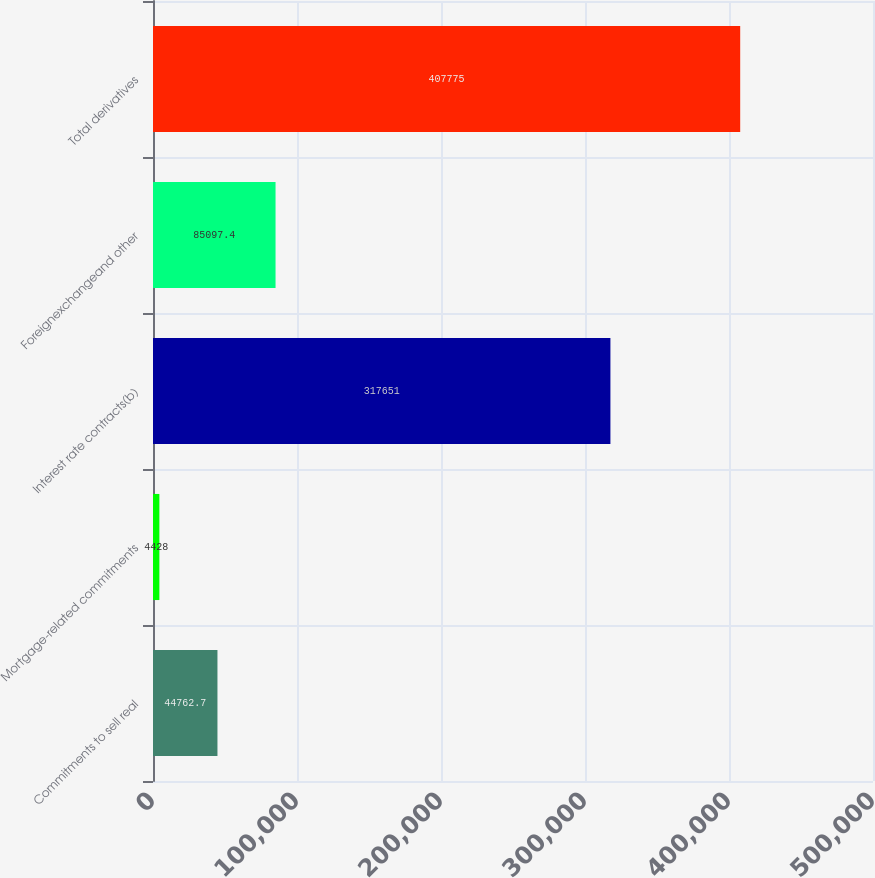Convert chart. <chart><loc_0><loc_0><loc_500><loc_500><bar_chart><fcel>Commitments to sell real<fcel>Mortgage-related commitments<fcel>Interest rate contracts(b)<fcel>Foreignexchangeand other<fcel>Total derivatives<nl><fcel>44762.7<fcel>4428<fcel>317651<fcel>85097.4<fcel>407775<nl></chart> 